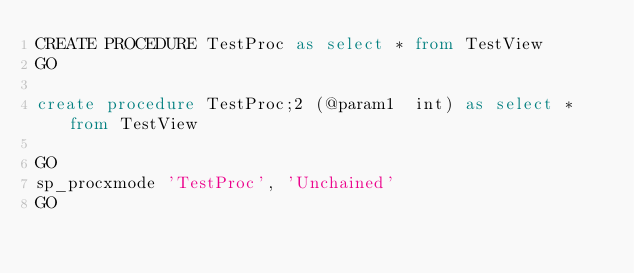<code> <loc_0><loc_0><loc_500><loc_500><_SQL_>CREATE PROCEDURE TestProc as select * from TestView
GO

create procedure TestProc;2 (@param1  int) as select * from TestView

GO
sp_procxmode 'TestProc', 'Unchained'
GO</code> 